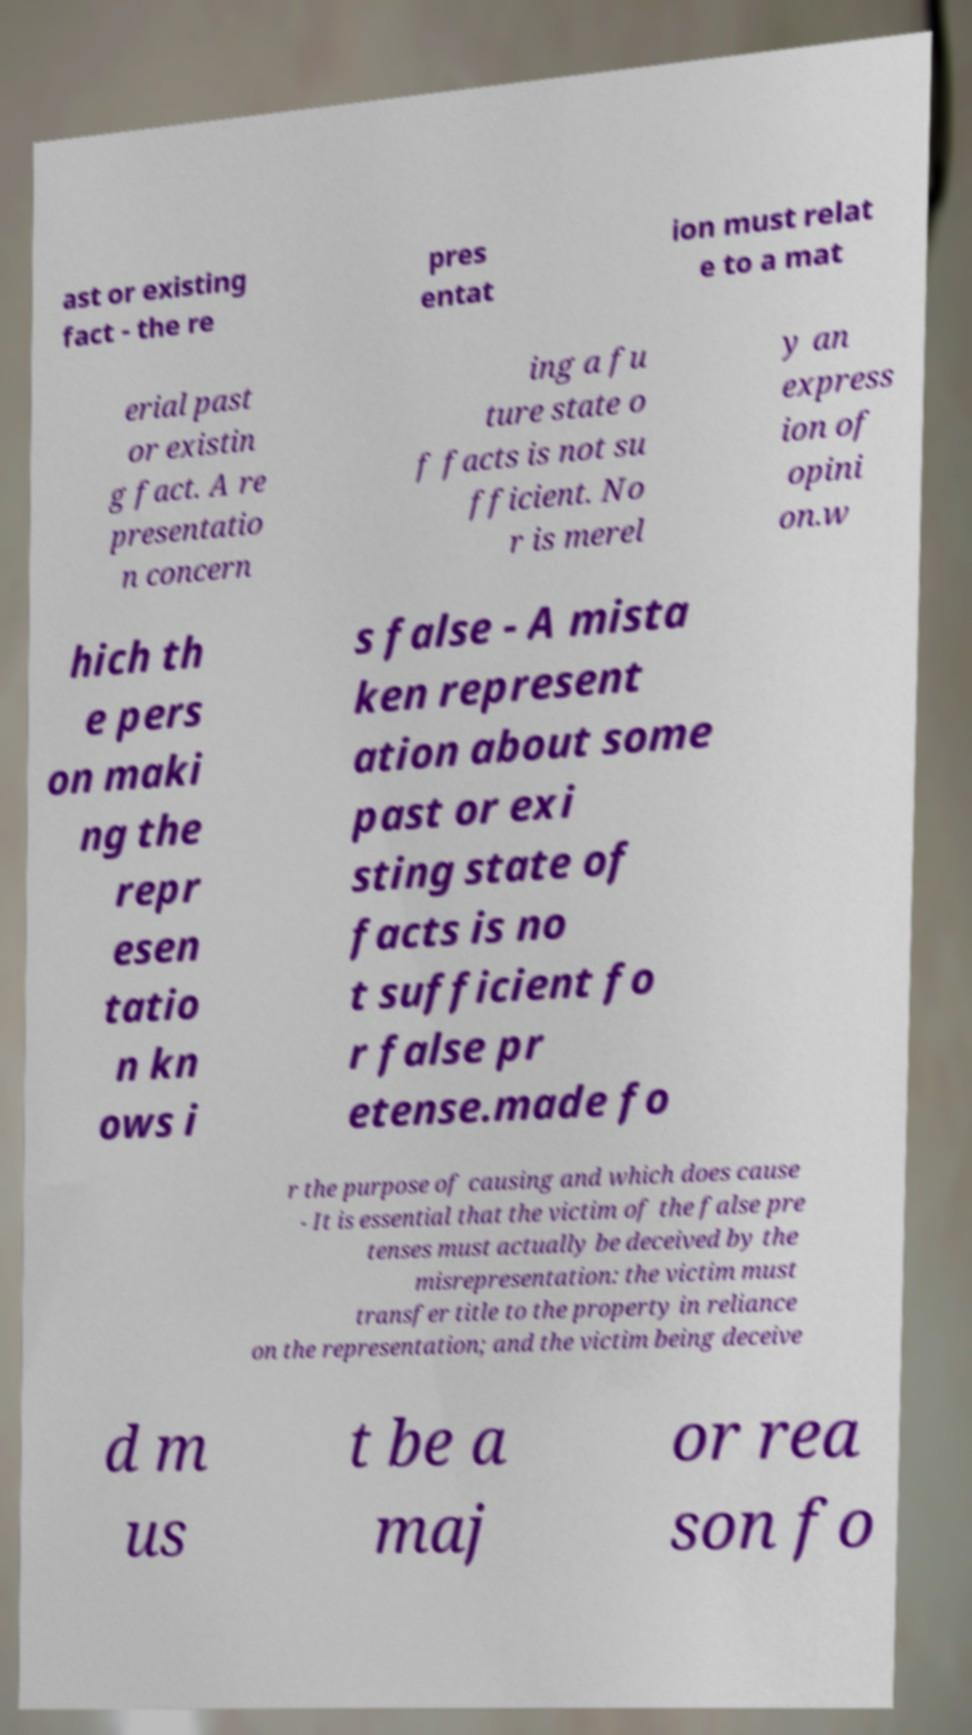I need the written content from this picture converted into text. Can you do that? ast or existing fact - the re pres entat ion must relat e to a mat erial past or existin g fact. A re presentatio n concern ing a fu ture state o f facts is not su fficient. No r is merel y an express ion of opini on.w hich th e pers on maki ng the repr esen tatio n kn ows i s false - A mista ken represent ation about some past or exi sting state of facts is no t sufficient fo r false pr etense.made fo r the purpose of causing and which does cause - It is essential that the victim of the false pre tenses must actually be deceived by the misrepresentation: the victim must transfer title to the property in reliance on the representation; and the victim being deceive d m us t be a maj or rea son fo 